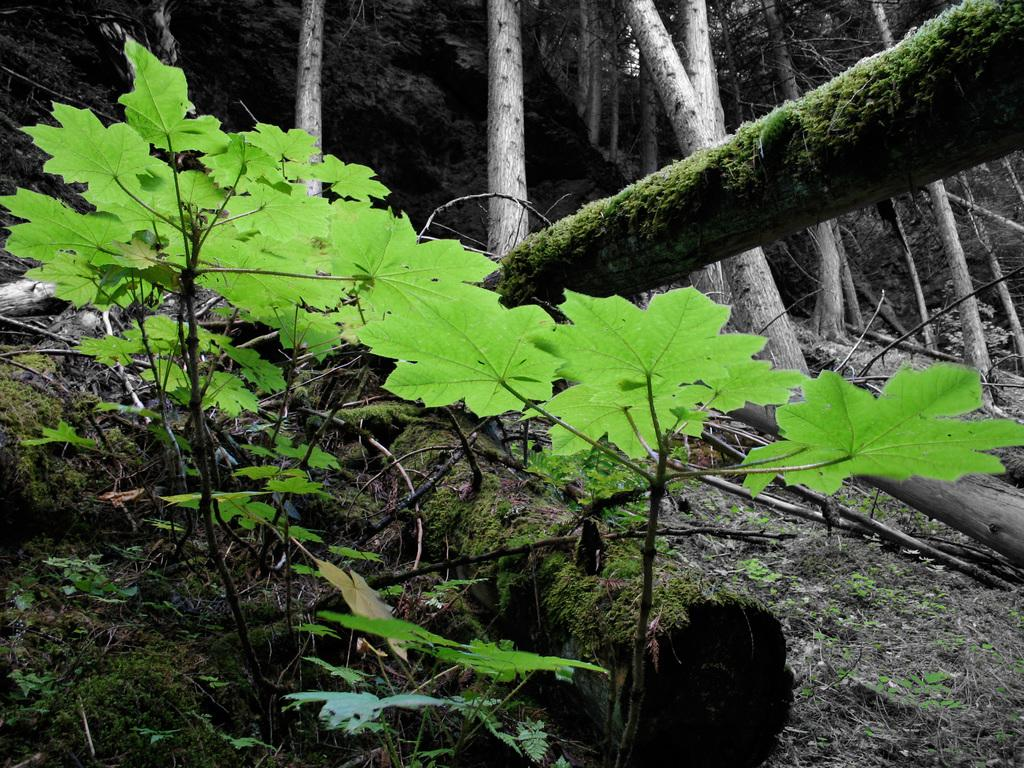What is located at the bottom of the image? There is a plant at the bottom of the image. What part of the plant is visible in the middle of the image? The leaves of the plant are visible in the middle of the image. What type of vegetation can be seen at the top of the image? There are trees at the top of the image. What type of cakes are being displayed on the art exhibit in the image? There is no mention of cakes or an art exhibit in the image; it features a plant with visible leaves and trees in the background. 